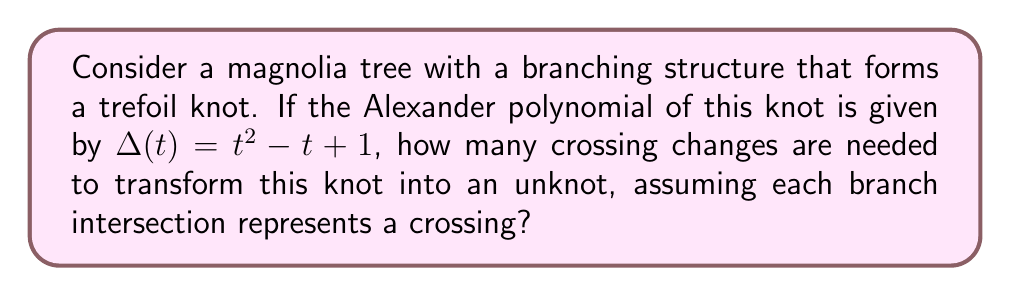What is the answer to this math problem? To solve this problem, we'll follow these steps:

1) First, recall that the Alexander polynomial of a trefoil knot is indeed $\Delta(t) = t^2 - t + 1$.

2) The unknotting number of a knot is the minimum number of crossing changes needed to transform the knot into an unknot.

3) For alternating knots (which includes the trefoil), there's a theorem by Kronheimer and Mrowka that relates the unknotting number to the degree of the Alexander polynomial:

   $u(K) \geq \frac{1}{2}\deg(\Delta_K(t))$

   Where $u(K)$ is the unknotting number and $\deg(\Delta_K(t))$ is the degree of the Alexander polynomial.

4) In our case, $\deg(\Delta(t)) = 2$, so:

   $u(K) \geq \frac{1}{2} \cdot 2 = 1$

5) This means we need at least one crossing change to unknot the trefoil.

6) In fact, for the trefoil knot, one crossing change is sufficient to unknot it.

Therefore, assuming each branch intersection in our magnolia tree represents a crossing in the trefoil knot structure, we need exactly one crossing change (or one branch rearrangement) to transform this knot into an unknot.
Answer: 1 